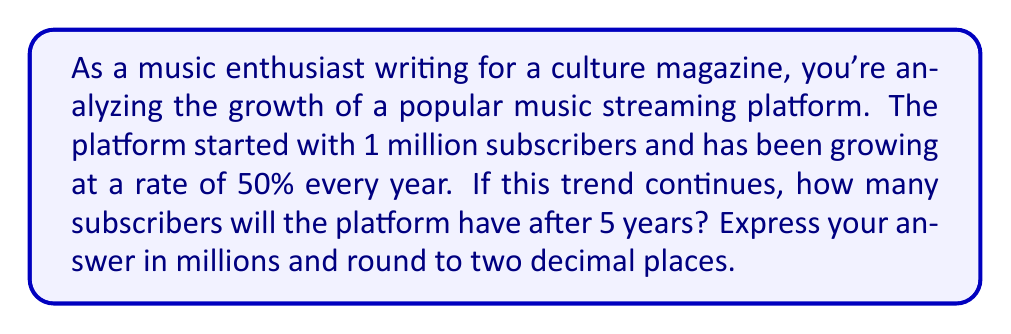Solve this math problem. Let's approach this step-by-step:

1) We start with 1 million subscribers.
2) The growth rate is 50% per year, which means we multiply by 1.5 each year.
3) We need to calculate this for 5 years.

Mathematically, we can express this as:

$$ \text{Subscribers after 5 years} = 1 \times (1.5)^5 $$

Let's calculate:

$$ \begin{align}
1 \times (1.5)^5 &= 1 \times 1.5 \times 1.5 \times 1.5 \times 1.5 \times 1.5 \\
&= 1 \times 7.59375 \\
&= 7.59375 \text{ million}
\end{align} $$

Rounding to two decimal places:

$$ 7.59375 \approx 7.59 \text{ million} $$

This exponential growth demonstrates the rapid expansion of music streaming platforms, a trend that's reshaping the music industry and how we consume music.
Answer: 7.59 million subscribers 